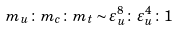Convert formula to latex. <formula><loc_0><loc_0><loc_500><loc_500>m _ { u } \colon m _ { c } \colon m _ { t } \sim \varepsilon _ { u } ^ { 8 } \colon \varepsilon _ { u } ^ { 4 } \colon 1</formula> 